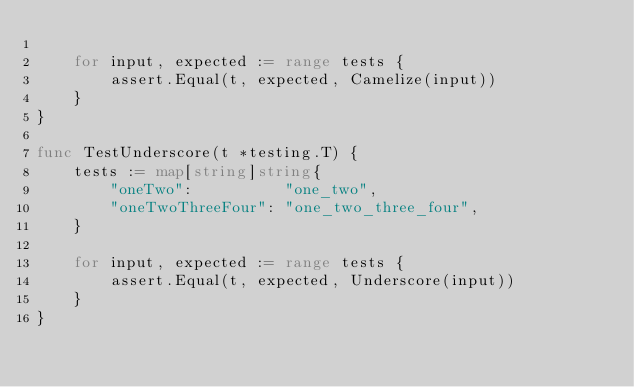Convert code to text. <code><loc_0><loc_0><loc_500><loc_500><_Go_>
	for input, expected := range tests {
		assert.Equal(t, expected, Camelize(input))
	}
}

func TestUnderscore(t *testing.T) {
	tests := map[string]string{
		"oneTwo":          "one_two",
		"oneTwoThreeFour": "one_two_three_four",
	}

	for input, expected := range tests {
		assert.Equal(t, expected, Underscore(input))
	}
}
</code> 